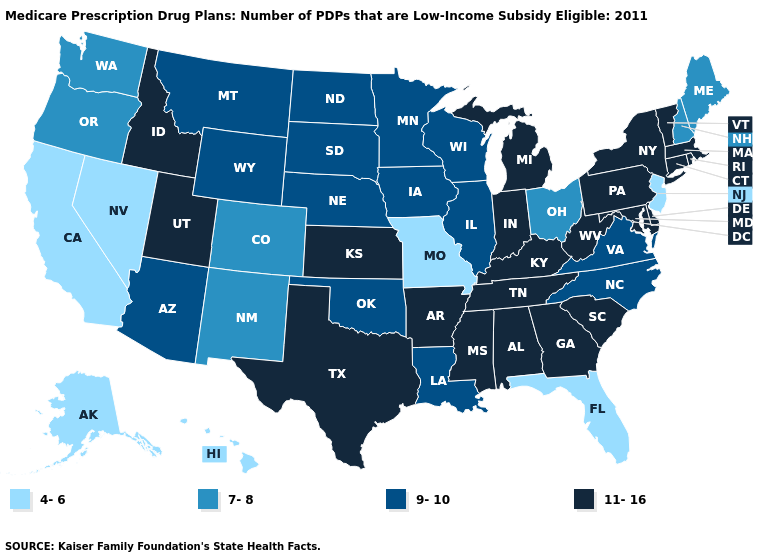What is the value of Arkansas?
Concise answer only. 11-16. What is the value of Arizona?
Write a very short answer. 9-10. Among the states that border Missouri , does Kentucky have the highest value?
Write a very short answer. Yes. Which states hav the highest value in the MidWest?
Be succinct. Indiana, Kansas, Michigan. Name the states that have a value in the range 4-6?
Be succinct. Alaska, California, Florida, Hawaii, Missouri, New Jersey, Nevada. Which states have the lowest value in the South?
Be succinct. Florida. What is the lowest value in the USA?
Write a very short answer. 4-6. What is the value of Maine?
Concise answer only. 7-8. How many symbols are there in the legend?
Short answer required. 4. What is the value of Washington?
Quick response, please. 7-8. Name the states that have a value in the range 7-8?
Quick response, please. Colorado, Maine, New Hampshire, New Mexico, Ohio, Oregon, Washington. Does the map have missing data?
Write a very short answer. No. Name the states that have a value in the range 9-10?
Quick response, please. Arizona, Iowa, Illinois, Louisiana, Minnesota, Montana, North Carolina, North Dakota, Nebraska, Oklahoma, South Dakota, Virginia, Wisconsin, Wyoming. What is the value of West Virginia?
Write a very short answer. 11-16. Name the states that have a value in the range 11-16?
Write a very short answer. Alabama, Arkansas, Connecticut, Delaware, Georgia, Idaho, Indiana, Kansas, Kentucky, Massachusetts, Maryland, Michigan, Mississippi, New York, Pennsylvania, Rhode Island, South Carolina, Tennessee, Texas, Utah, Vermont, West Virginia. 